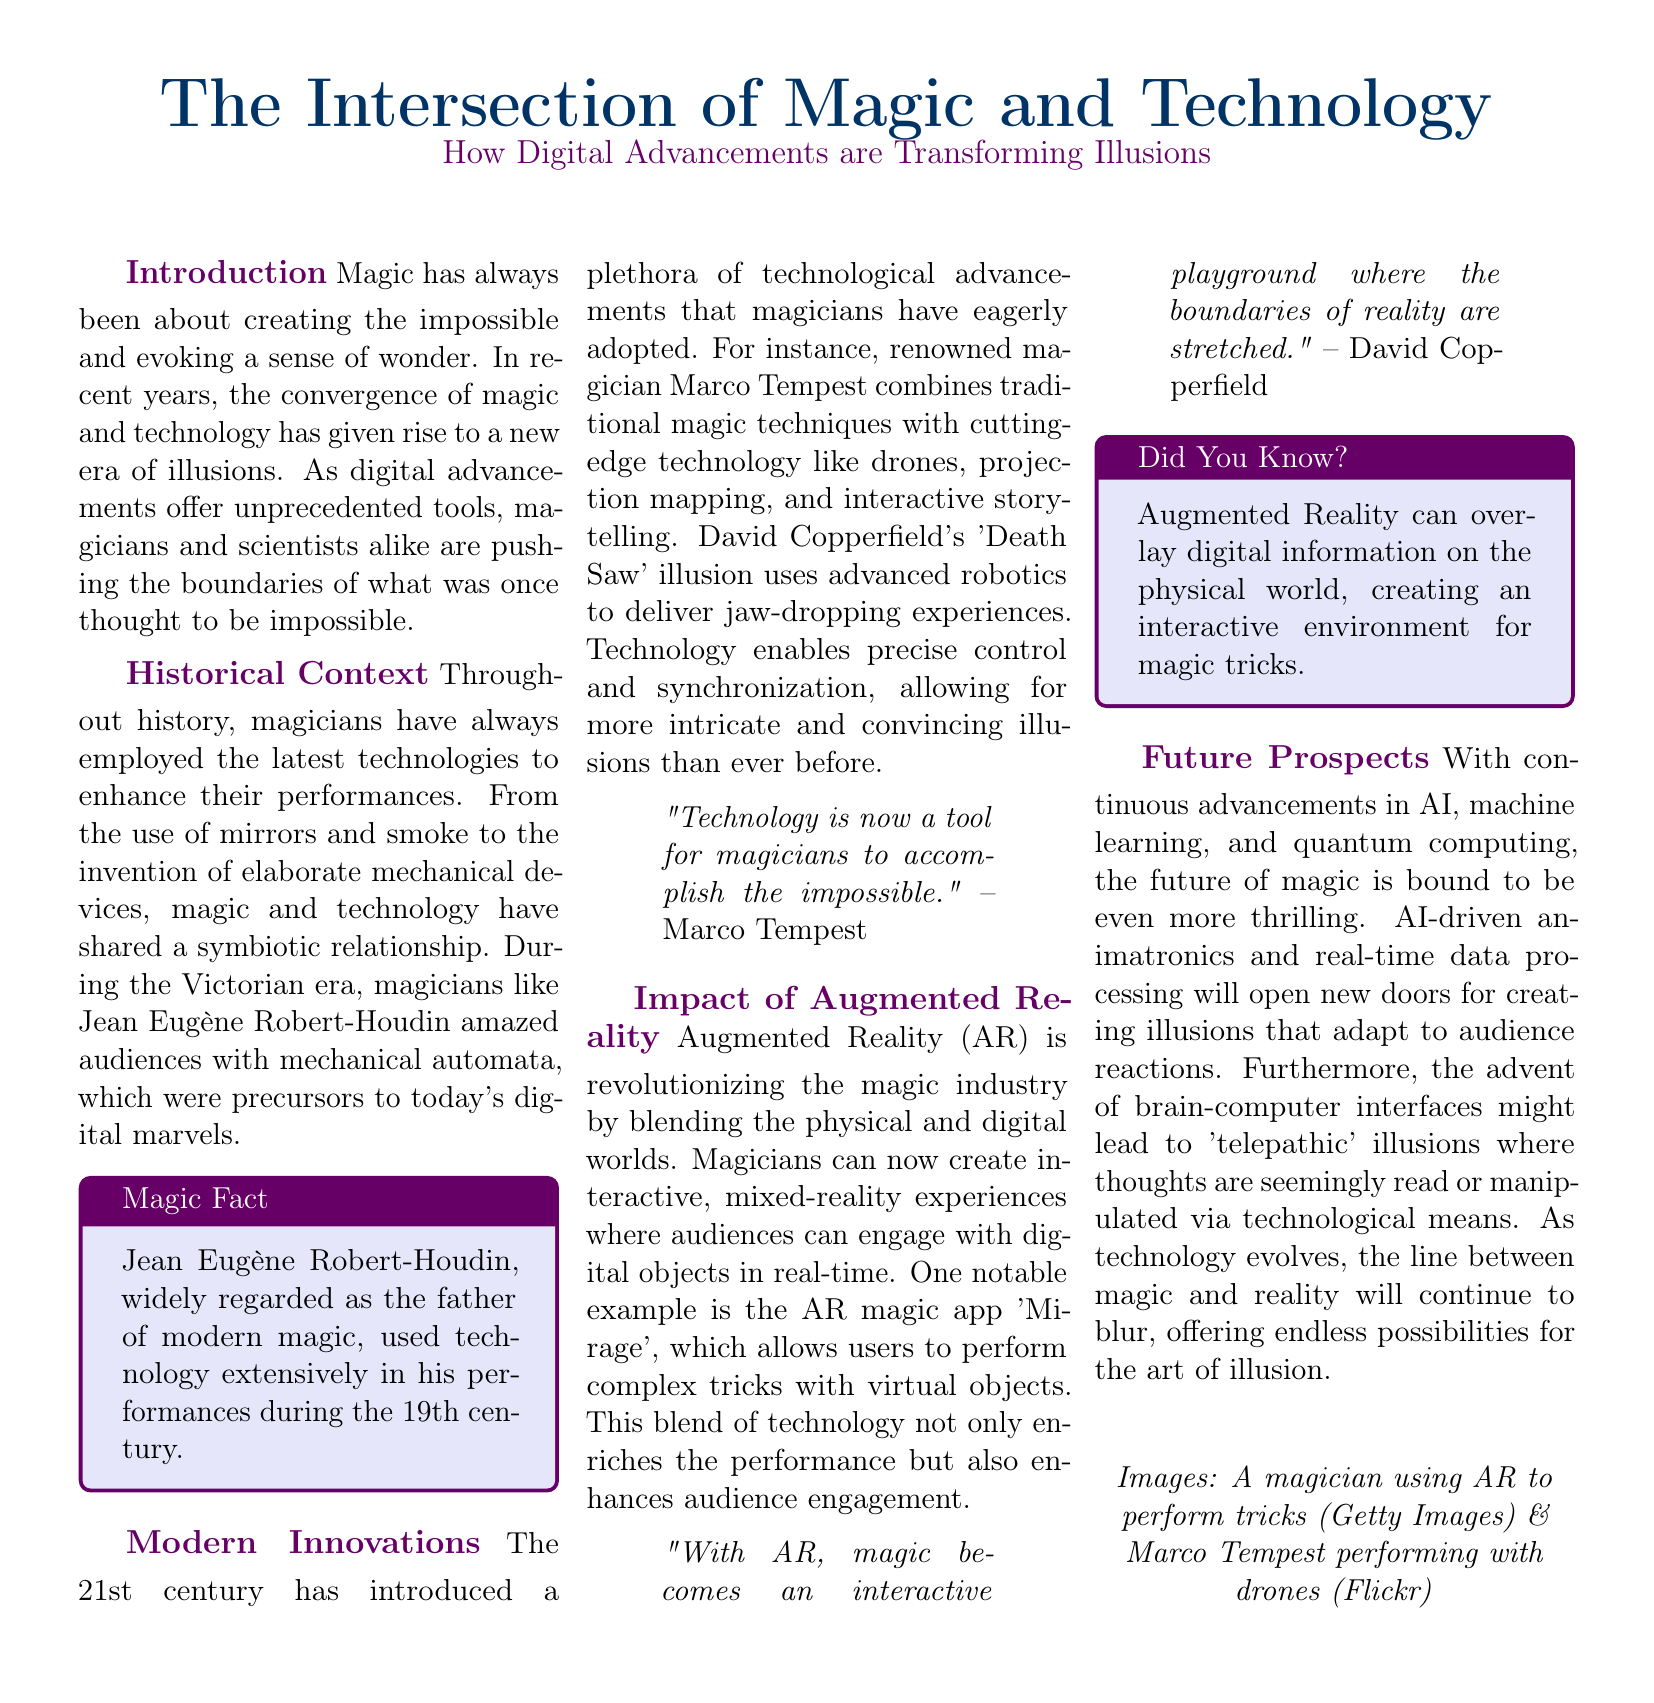What is the title of the article? The title is prominently displayed at the top of the document, indicating the main focus.
Answer: The Intersection of Magic and Technology Who is considered the father of modern magic? The document provides historical context about influential magicians and identifies a key figure.
Answer: Jean Eugène Robert-Houdin What technology does Marco Tempest incorporate into his performances? The section on modern innovations details specific technologies used by contemporary magicians.
Answer: Drones What does the AR magic app 'Mirage' allow users to do? The document explains the functionality and purpose of the AR app in enhancing magical experiences.
Answer: Perform complex tricks with virtual objects What does David Copperfield describe AR magic as? The quote highlights Copperfield's perspective on the role of AR in magic, reflecting his visionary view.
Answer: An interactive playground How do future advancements like AI impact magic? The future prospects section discusses technological trends influencing the evolution of magic performances.
Answer: Thrilling What was the historical technology used by magicians during the Victorian era? Historical context reveals the types of technologies utilized in earlier magic performances.
Answer: Mechanical automata What is the color used for the headline in the document? The visual layout specifies colors chosen for different sections, including the headline.
Answer: RGB(0,51,102) What is a key feature of augmented reality in magic according to the document? The impact section underlines the unique features and enhancements AR brings to magic shows.
Answer: Interactive, mixed-reality experiences 